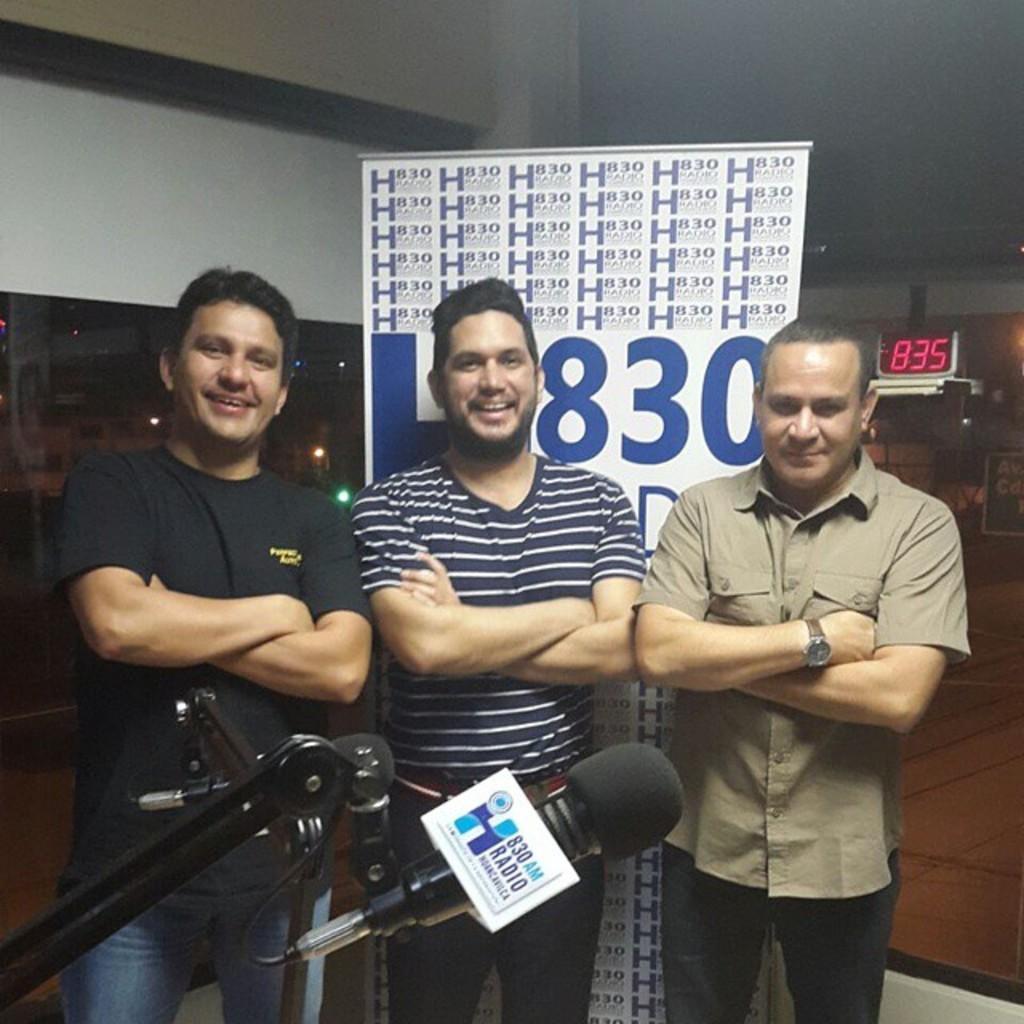Describe this image in one or two sentences. There are three men standing and smiling. This is the mike, which is attached to the stand. This looks like a banner with letters on it. In the background, I can see a digital clock. I think this is the glass window. 